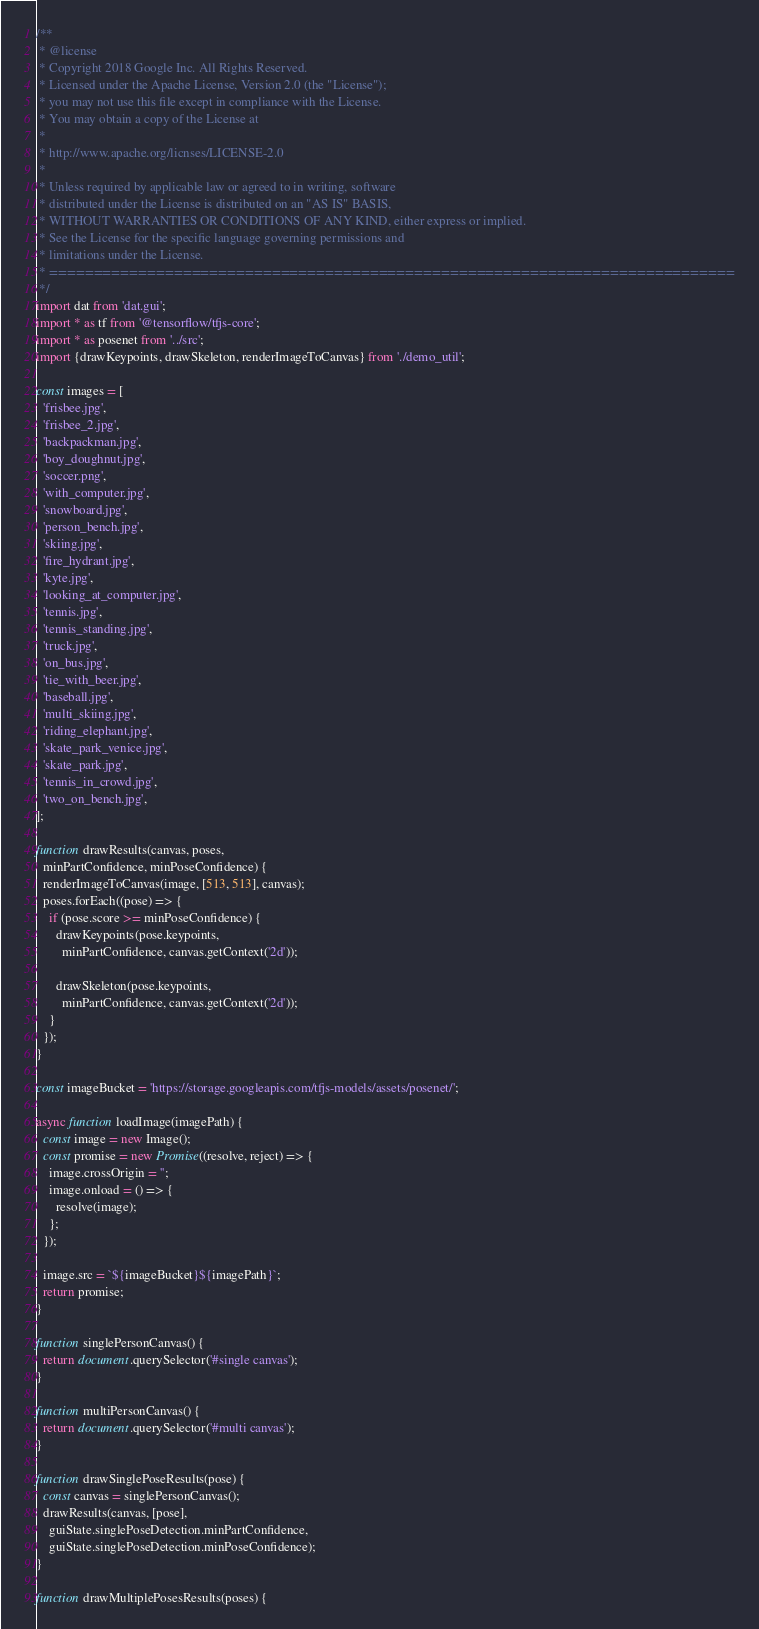<code> <loc_0><loc_0><loc_500><loc_500><_TypeScript_>/**
 * @license
 * Copyright 2018 Google Inc. All Rights Reserved.
 * Licensed under the Apache License, Version 2.0 (the "License");
 * you may not use this file except in compliance with the License.
 * You may obtain a copy of the License at
 *
 * http://www.apache.org/licnses/LICENSE-2.0
 *
 * Unless required by applicable law or agreed to in writing, software
 * distributed under the License is distributed on an "AS IS" BASIS,
 * WITHOUT WARRANTIES OR CONDITIONS OF ANY KIND, either express or implied.
 * See the License for the specific language governing permissions and
 * limitations under the License.
 * =============================================================================
 */
import dat from 'dat.gui';
import * as tf from '@tensorflow/tfjs-core';
import * as posenet from '../src';
import {drawKeypoints, drawSkeleton, renderImageToCanvas} from './demo_util';

const images = [
  'frisbee.jpg',
  'frisbee_2.jpg',
  'backpackman.jpg',
  'boy_doughnut.jpg',
  'soccer.png',
  'with_computer.jpg',
  'snowboard.jpg',
  'person_bench.jpg',
  'skiing.jpg',
  'fire_hydrant.jpg',
  'kyte.jpg',
  'looking_at_computer.jpg',
  'tennis.jpg',
  'tennis_standing.jpg',
  'truck.jpg',
  'on_bus.jpg',
  'tie_with_beer.jpg',
  'baseball.jpg',
  'multi_skiing.jpg',
  'riding_elephant.jpg',
  'skate_park_venice.jpg',
  'skate_park.jpg',
  'tennis_in_crowd.jpg',
  'two_on_bench.jpg',
];

function drawResults(canvas, poses,
  minPartConfidence, minPoseConfidence) {
  renderImageToCanvas(image, [513, 513], canvas);
  poses.forEach((pose) => {
    if (pose.score >= minPoseConfidence) {
      drawKeypoints(pose.keypoints,
        minPartConfidence, canvas.getContext('2d'));

      drawSkeleton(pose.keypoints,
        minPartConfidence, canvas.getContext('2d'));
    }
  });
}

const imageBucket = 'https://storage.googleapis.com/tfjs-models/assets/posenet/';

async function loadImage(imagePath) {
  const image = new Image();
  const promise = new Promise((resolve, reject) => {
    image.crossOrigin = '';
    image.onload = () => {
      resolve(image);
    };
  });

  image.src = `${imageBucket}${imagePath}`;
  return promise;
}

function singlePersonCanvas() {
  return document.querySelector('#single canvas');
}

function multiPersonCanvas() {
  return document.querySelector('#multi canvas');
}

function drawSinglePoseResults(pose) {
  const canvas = singlePersonCanvas();
  drawResults(canvas, [pose],
    guiState.singlePoseDetection.minPartConfidence,
    guiState.singlePoseDetection.minPoseConfidence);
}

function drawMultiplePosesResults(poses) {</code> 